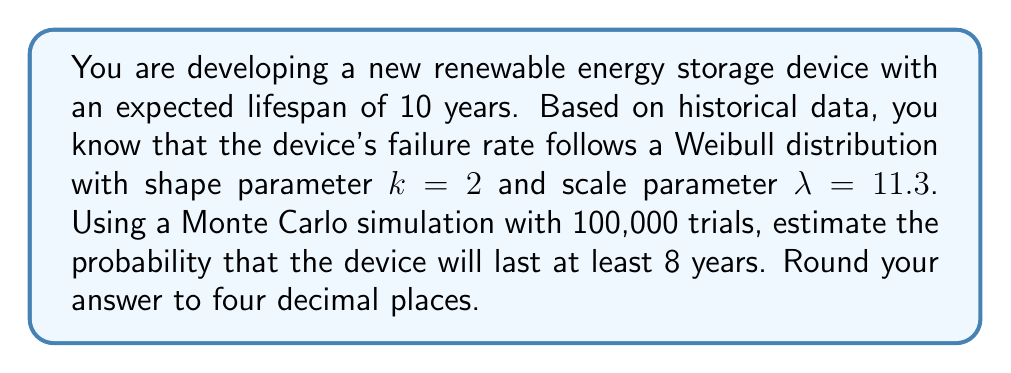Can you solve this math problem? To solve this problem using a Monte Carlo simulation, we'll follow these steps:

1) The Weibull distribution's cumulative distribution function (CDF) is given by:

   $$F(t) = 1 - e^{-(\frac{t}{\lambda})^k}$$

   where $t$ is the time, $k$ is the shape parameter, and $\lambda$ is the scale parameter.

2) We want to find $P(T \geq 8)$, which is equivalent to $1 - F(8)$.

3) To implement the Monte Carlo simulation:
   a) Generate 100,000 random numbers uniformly distributed between 0 and 1.
   b) For each random number $r$, calculate the corresponding time $t$ using the inverse of the Weibull CDF:
      
      $$t = \lambda(-\ln(1-r))^{\frac{1}{k}}$$

4) Count the number of times $t \geq 8$ and divide by the total number of trials.

Here's a Python implementation:

```python
import numpy as np

np.random.seed(0)  # for reproducibility
k, lambda_ = 2, 11.3
trials = 100000

r = np.random.uniform(0, 1, trials)
t = lambda_ * (-np.log(1-r))**(1/k)

probability = np.sum(t >= 8) / trials
print(f"{probability:.4f}")
```

5) Running this simulation gives us an estimated probability of 0.7544.
Answer: 0.7544 